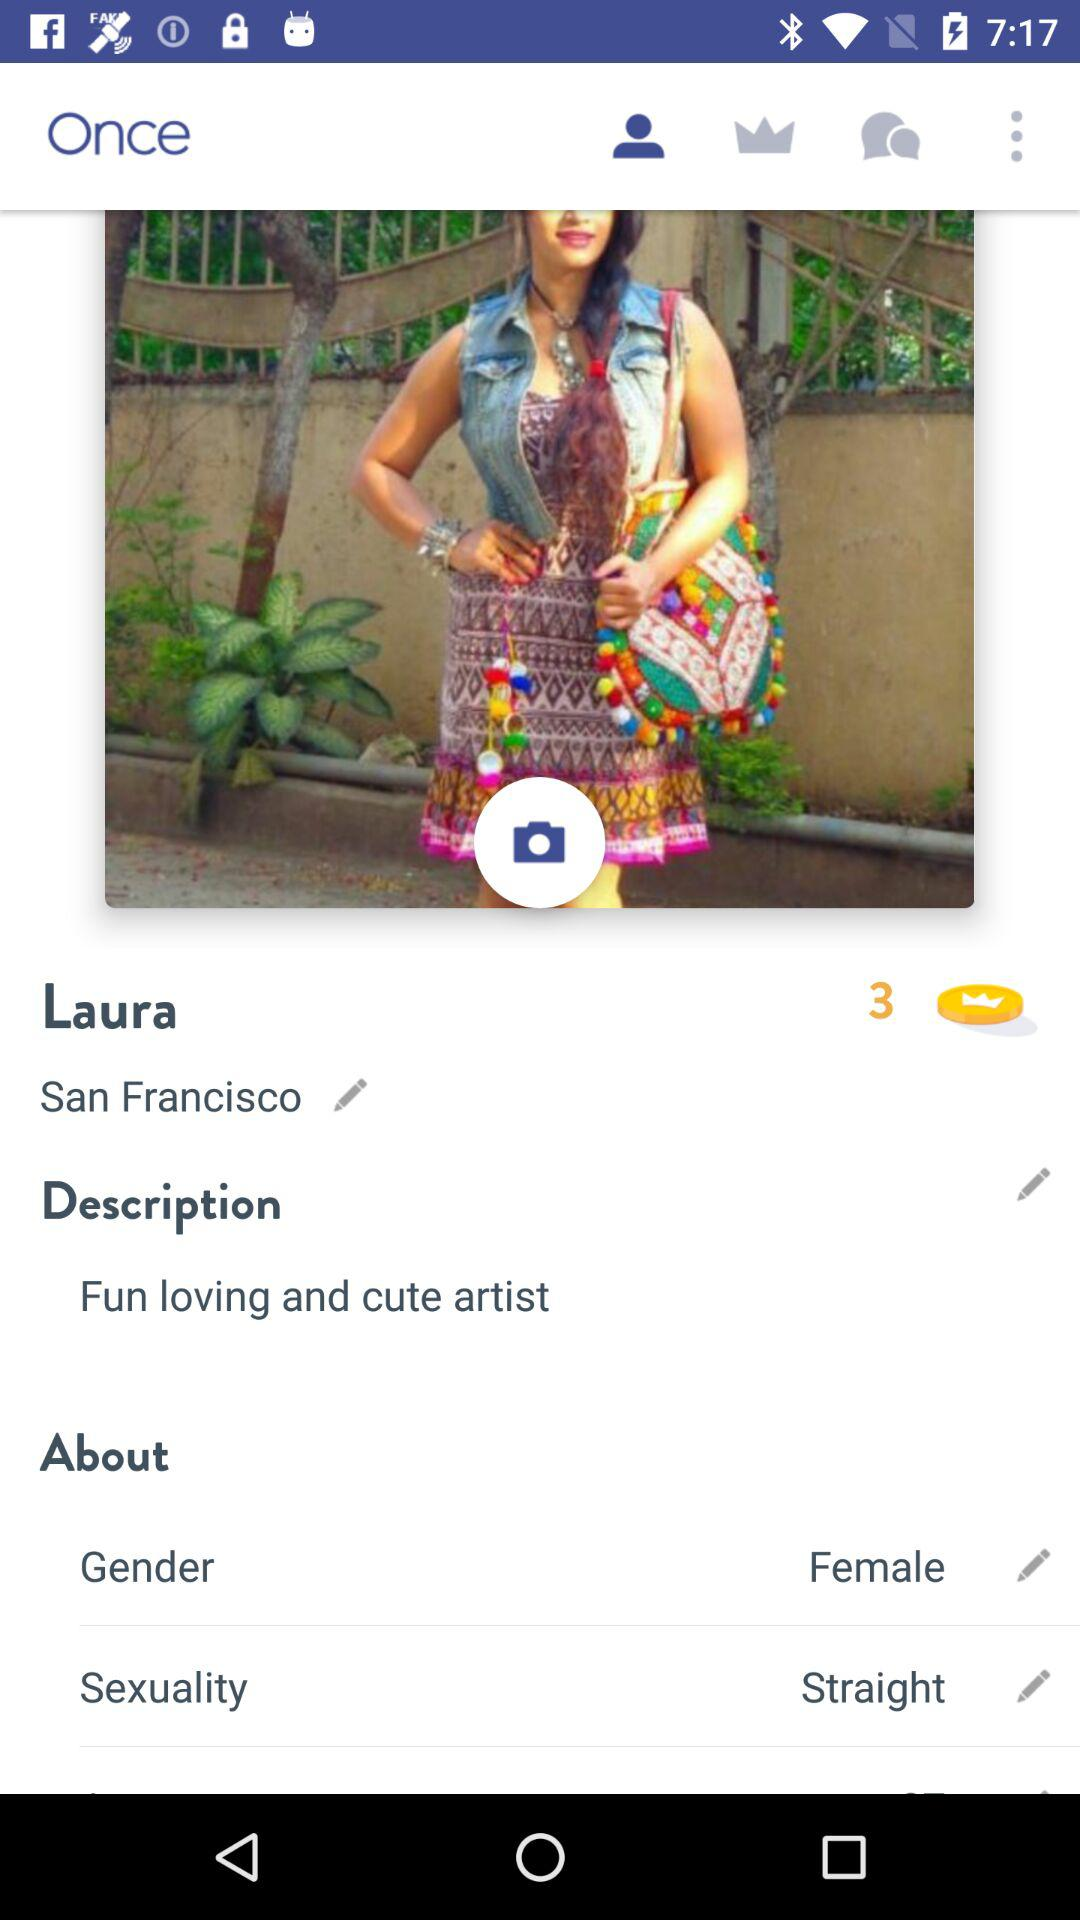What is the name of the user? The name of the user is Laura. 